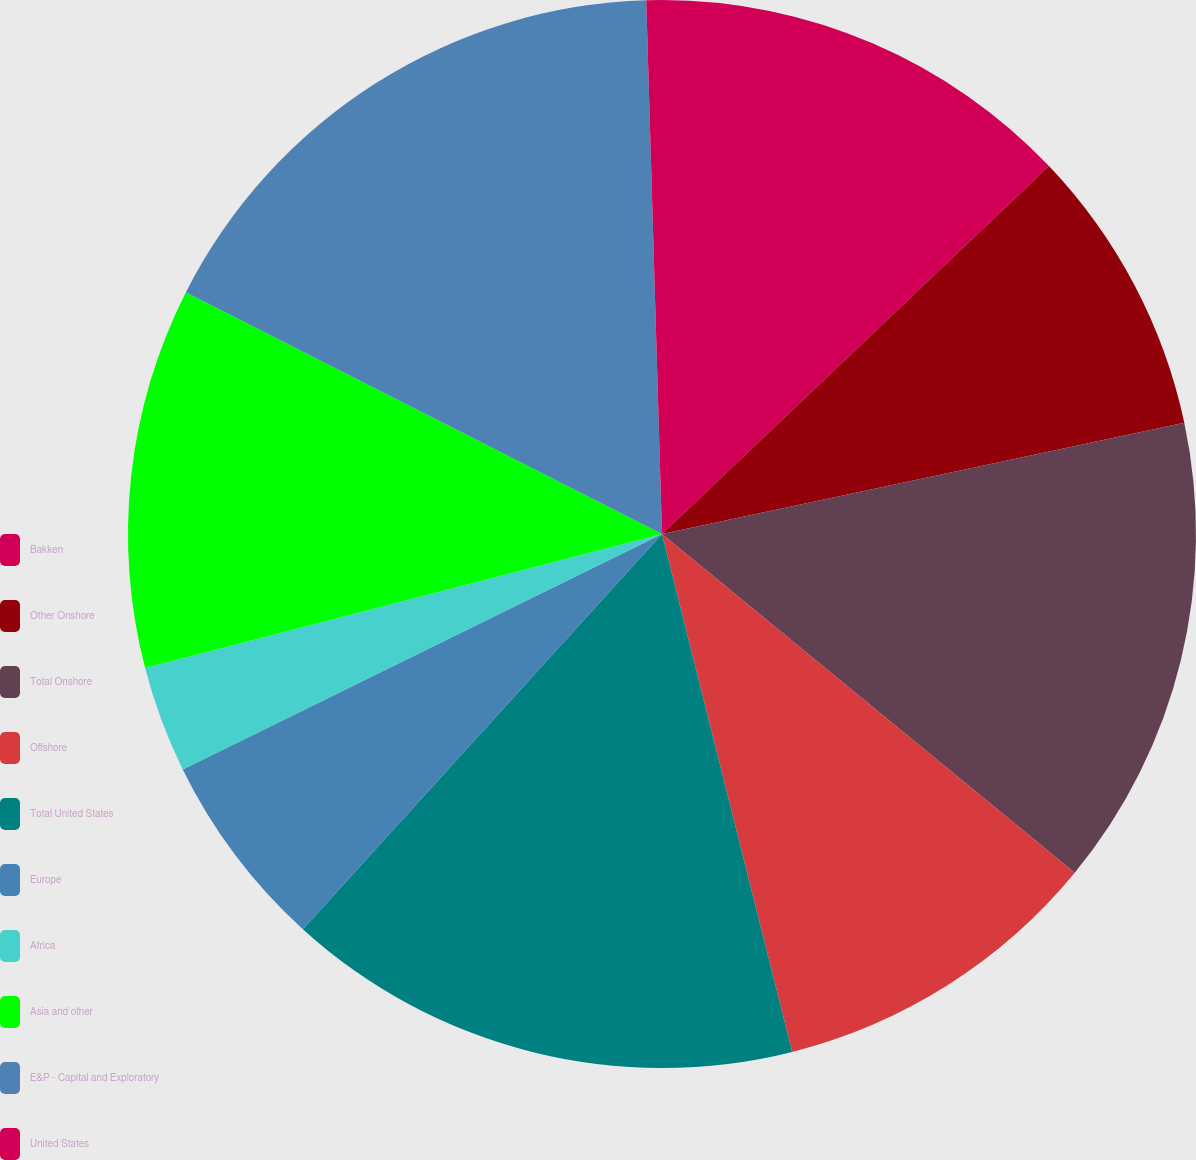<chart> <loc_0><loc_0><loc_500><loc_500><pie_chart><fcel>Bakken<fcel>Other Onshore<fcel>Total Onshore<fcel>Offshore<fcel>Total United States<fcel>Europe<fcel>Africa<fcel>Asia and other<fcel>E&P - Capital and Exploratory<fcel>United States<nl><fcel>12.9%<fcel>8.76%<fcel>14.28%<fcel>10.14%<fcel>15.66%<fcel>5.99%<fcel>3.23%<fcel>11.52%<fcel>17.05%<fcel>0.47%<nl></chart> 